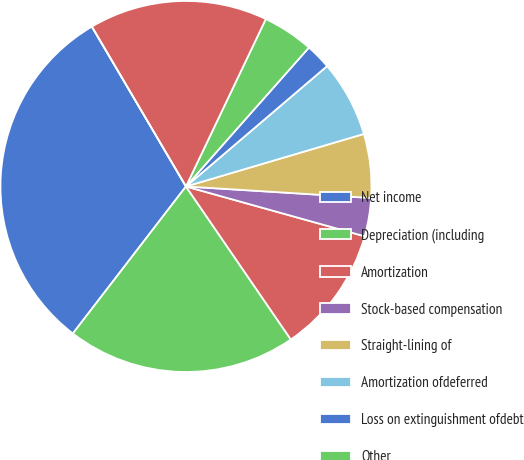<chart> <loc_0><loc_0><loc_500><loc_500><pie_chart><fcel>Net income<fcel>Depreciation (including<fcel>Amortization<fcel>Stock-based compensation<fcel>Straight-lining of<fcel>Amortization ofdeferred<fcel>Loss on extinguishment ofdebt<fcel>Other<fcel>(Increase) decrease in escrow<fcel>Increase in other assets<nl><fcel>31.1%<fcel>20.0%<fcel>11.11%<fcel>3.34%<fcel>5.56%<fcel>6.67%<fcel>2.23%<fcel>4.45%<fcel>15.55%<fcel>0.0%<nl></chart> 